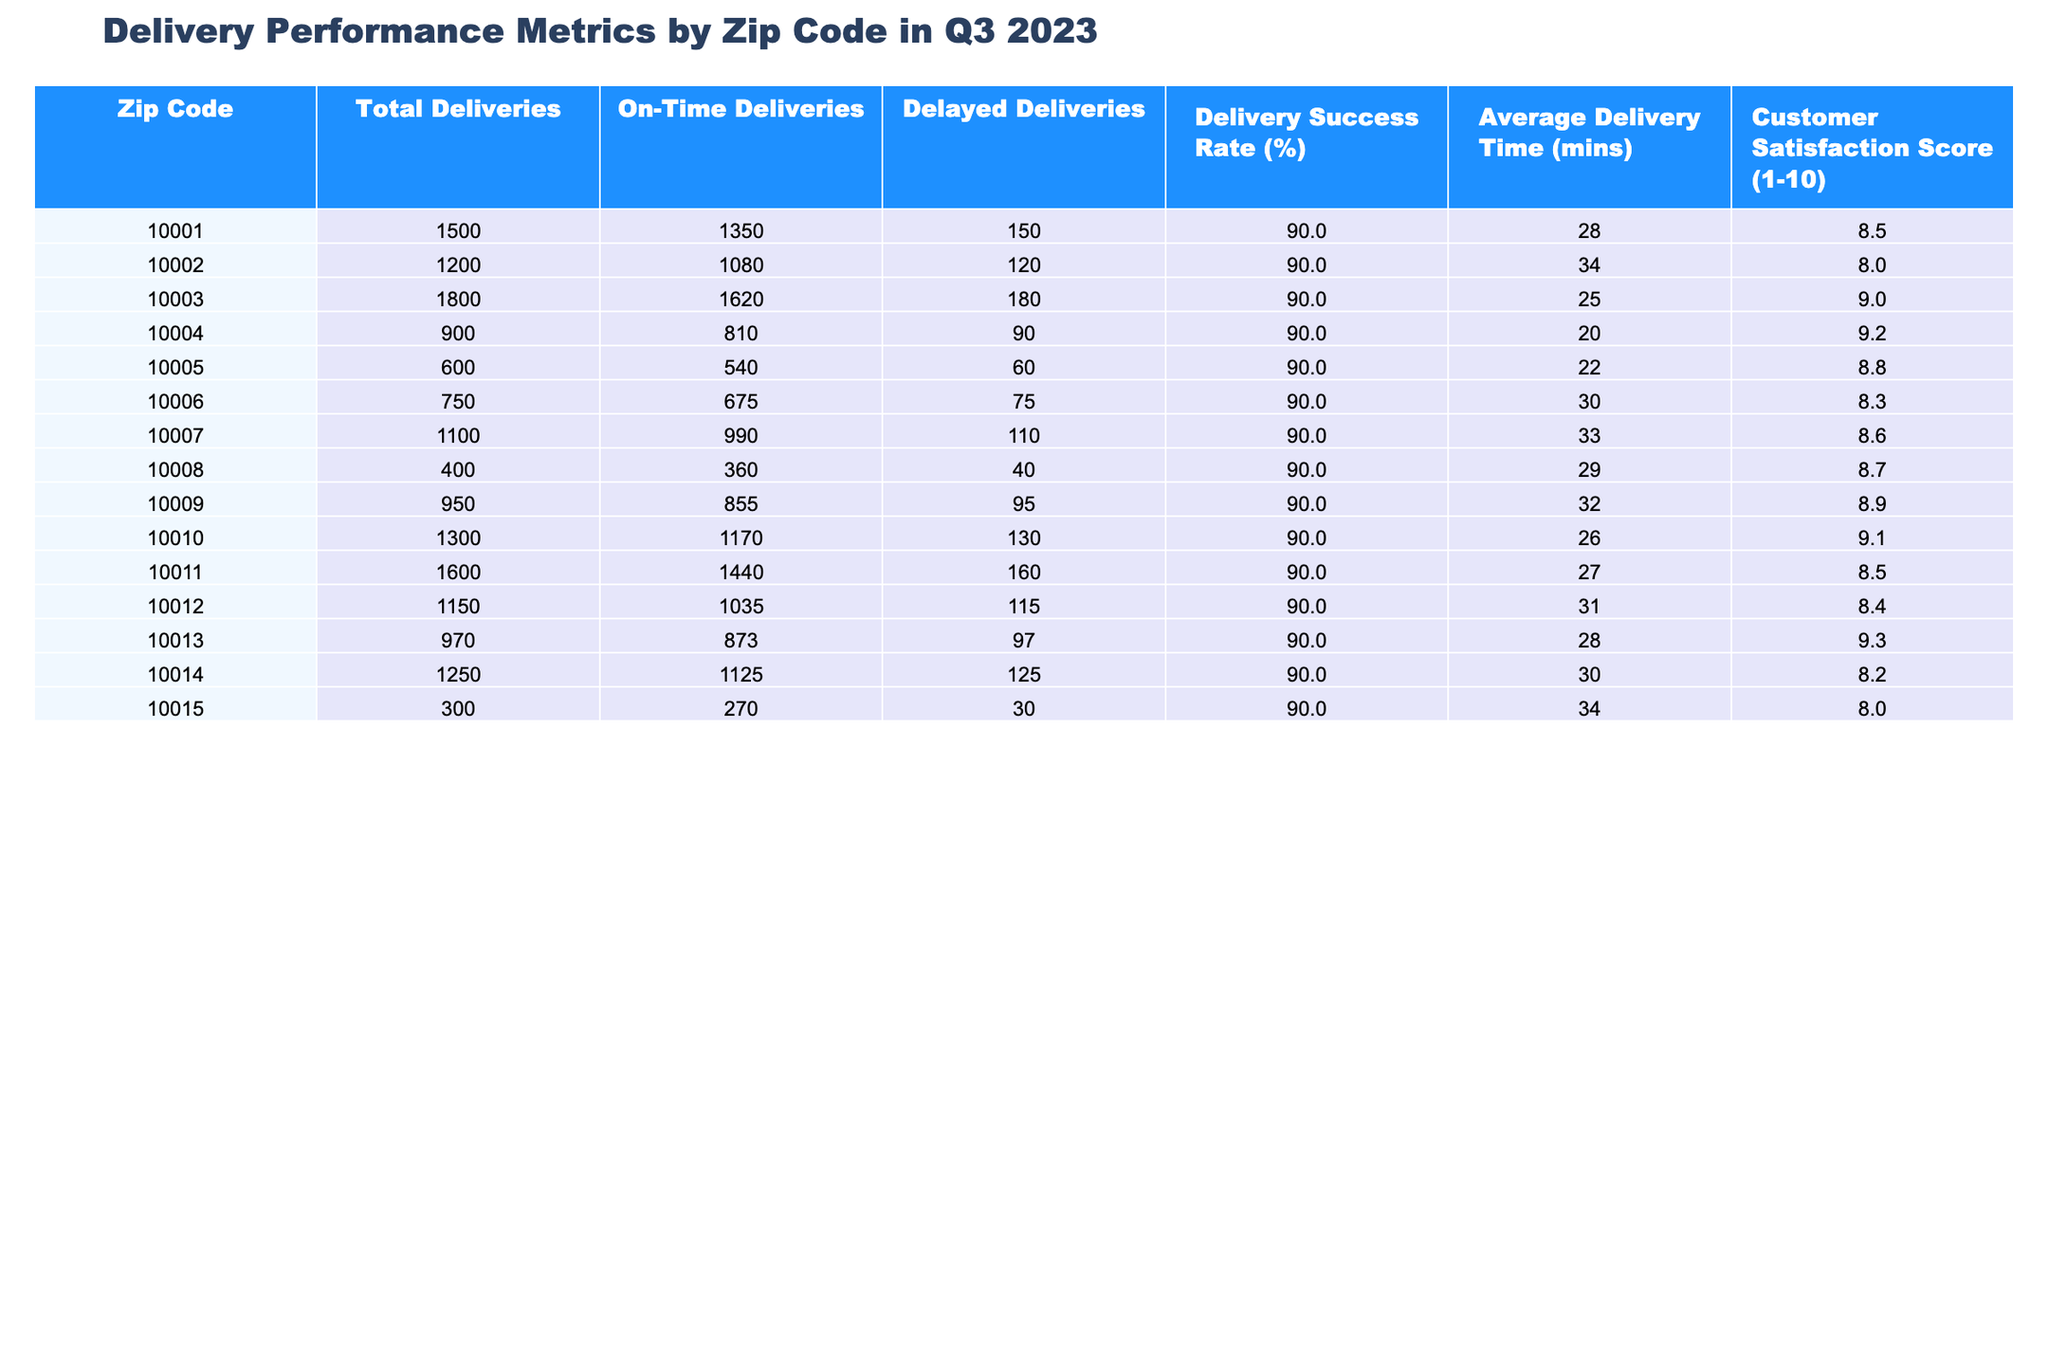What is the zip code with the highest customer satisfaction score? To find this, we can look through the Customer Satisfaction Score column for the maximum value. Upon inspecting, 10013 has the highest score of 9.3.
Answer: 10013 How many total deliveries were made in zip code 10005? Referring to the Total Deliveries column, the value for zip code 10005 is 600.
Answer: 600 What is the average delivery time for the zip code with the highest average delivery time? First, we need to identify the zip code with the highest value in the Average Delivery Time column. The highest value is 34 mins for both zip codes 10002 and 10015. Therefore, the average delivery time for these zip codes is 34 mins.
Answer: 34 How many delayed deliveries were there in zip code 10010? Looking at the Delayed Deliveries column, zip code 10010 has a value of 130 delayed deliveries.
Answer: 130 Is the Delivery Success Rate for all zip codes above 80%? Checking the Delivery Success Rate column, all listed rates are 90.0%, which is above 80%. Thus, the statement is true.
Answer: Yes What are the total on-time deliveries for zip codes starting with '1001'? We need to sum the On-Time Deliveries for zip codes 10001, 10002, 10003, and 10004. These are 1350 + 1080 + 1620 + 810 = 4060.
Answer: 4060 What is the percentage of delayed deliveries in zip code 10011? First, we find the total deliveries (1600) and the number of delayed deliveries (160). The percentage of delayed deliveries is (160 / 1600) * 100 = 10%.
Answer: 10% Which zip code had the lowest average delivery time? By inspecting the Average Delivery Time column, zip code 10004 has the lowest time of 20 minutes.
Answer: 10004 What is the difference in Customer Satisfaction Score between zip codes 10012 and 10008? The Customer Satisfaction Score for 10012 is 8.4 and for 10008 is 8.7. The difference is 8.7 - 8.4 = 0.3.
Answer: 0.3 How does the Delivery Success Rate for zip code 10014 compare to the average delivery success rate across all zip codes? The Delivery Success Rate for zip code 10014 is 90.0%. To determine how it compares, we find the average of the Delivery Success Rates across all zip codes, which is also 90.0%. Therefore, 10014's rate matches the average.
Answer: Matches the average 